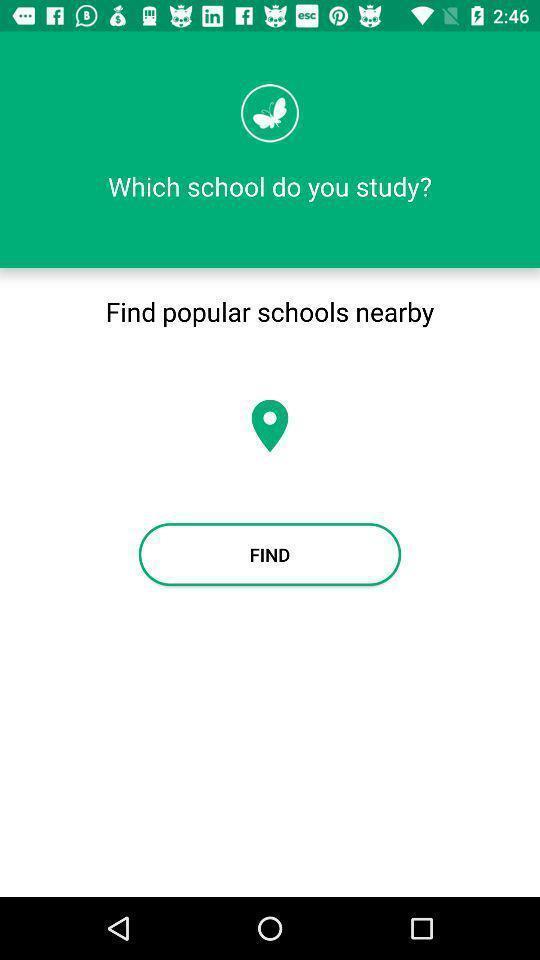Tell me what you see in this picture. Screen shows find location of schools. 